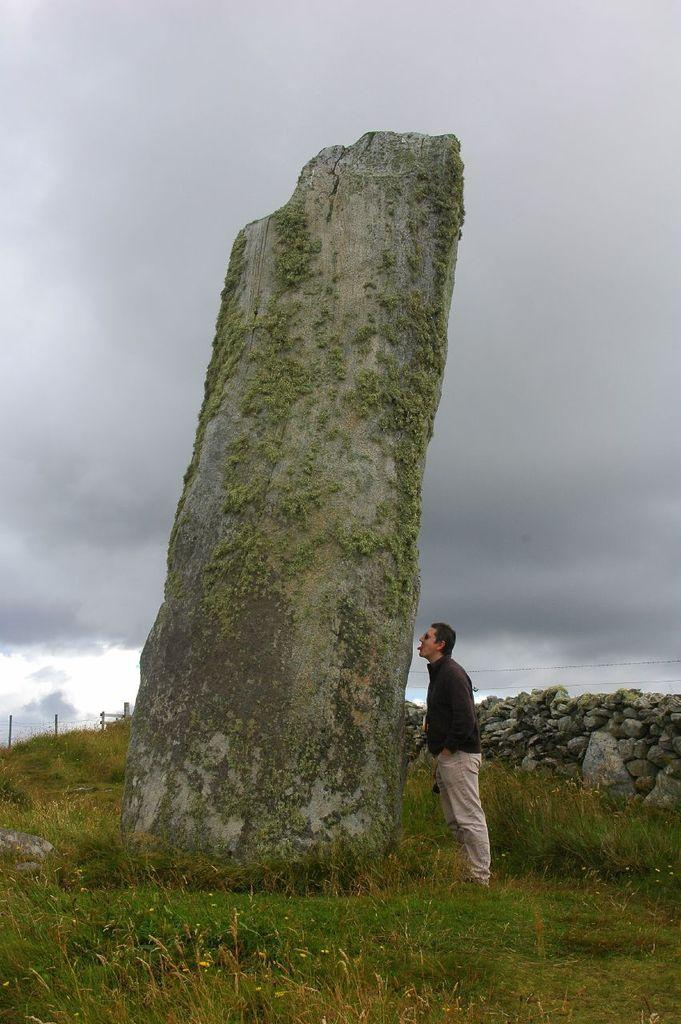What is the person in the image standing on? The person is standing on the grass in the image. What other natural element is visible in the image? There is a big rock in the image. Are there any man-made structures visible in the image? Yes, there is a stone wall and a fence in the image. What type of vegetation is present in the image? The grass is visible in the image. What can be seen in the sky in the background? The sky in the background is cloudy. What type of holiday is being celebrated in the image? There is no indication of a holiday being celebrated in the image. What thing is flowing through the image? There is no flowing thing present in the image. 